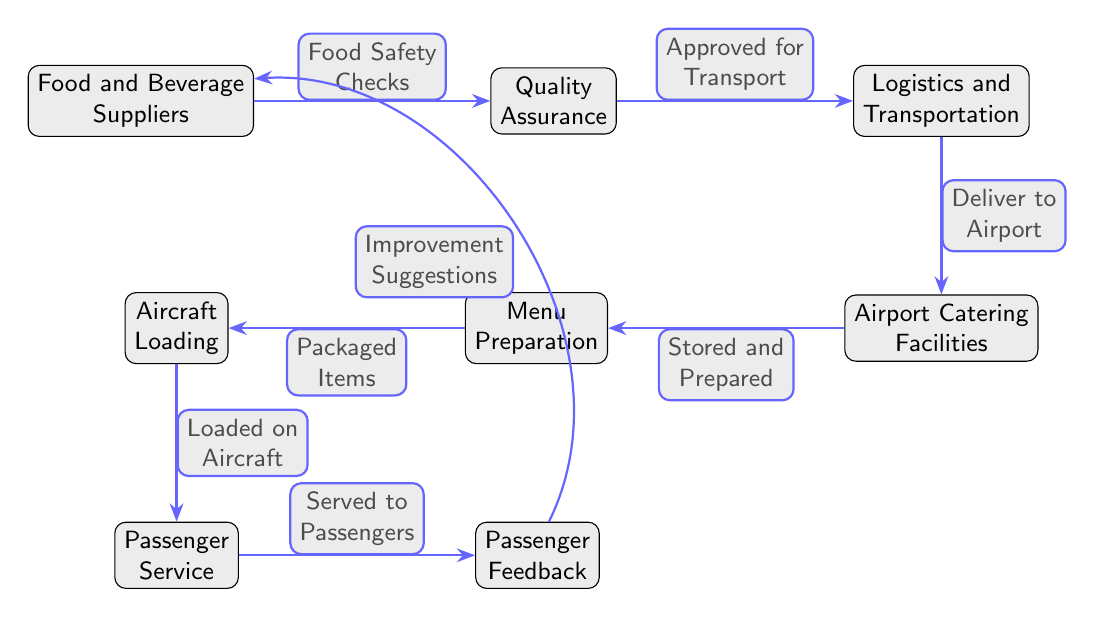What are the two main categories of suppliers shown in the diagram? The diagram specifies "Food and Beverage Suppliers" as the primary suppliers, but does not categorize them into distinct types. The focus is on the singular entity of 'suppliers' providing food and beverages.
Answer: Food and Beverage Suppliers What is the first step in the catering supply chain? The diagram indicates that the first step originates from the "Food and Beverage Suppliers," making it the first node in the flow.
Answer: Food and Beverage Suppliers How many nodes are in the supply chain? By counting each distinct section in the diagram, we have a total of eight nodes: Suppliers, Quality Assurance, Logistics and Transportation, Airport Catering Facilities, Menu Preparation, Aircraft Loading, Passenger Service, and Passenger Feedback.
Answer: 8 What happens after quality assurance? According to the diagram, following quality assurance, the next step is "Logistics and Transportation," which handles the approved food for delivery.
Answer: Logistics and Transportation Which step comes immediately before passenger service? The diagram illustrates "Aircraft Loading" as the step that precedes "Passenger Service," showing the direct flow of operations.
Answer: Aircraft Loading What kind of feedback is provided to the suppliers? The diagram indicates that the type of feedback provided to suppliers is "Improvement Suggestions," specifically directed as feedback from passengers.
Answer: Improvement Suggestions What is the action taken with the stored food? The diagram notes that the action taken with the stored food is "Packaged Items," where the prepared menu is organized before loading onto the aircraft.
Answer: Packaged Items What is the last node in the chain according to the diagram? Reviewing the flow of the diagram, the last node that completes the cycle of the supply chain is "Passenger Feedback." This indicates that this stage reflects back to the suppliers for improvements.
Answer: Passenger Feedback Which process delivers food to the airport? The diagram specifies "Logistics and Transportation" as the process responsible for delivering food to the airport catering facilities after the food passes quality checks.
Answer: Logistics and Transportation 